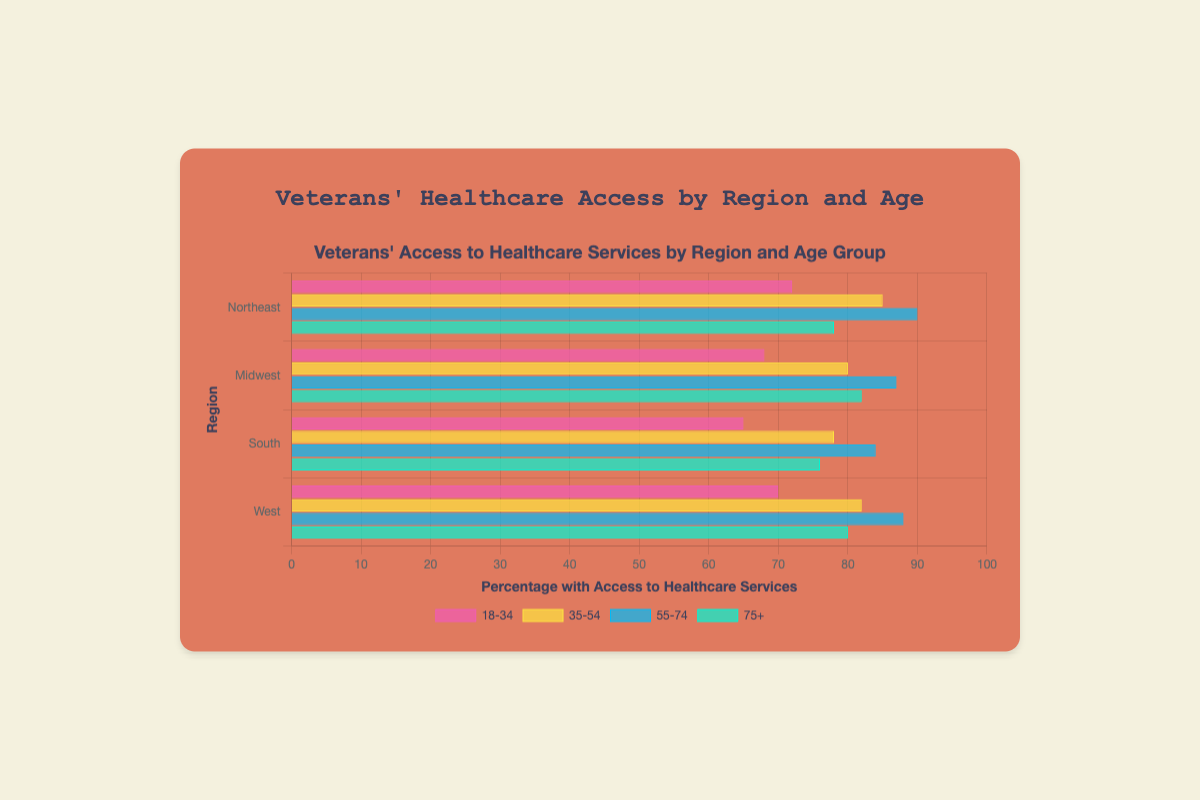Which region has the highest percentage access for the 18-34 age group? By looking at the bar lengths for the 18-34 age group, we can compare across the regions. The Northeast region has the highest percentage access with 72%.
Answer: Northeast Which age group has the lowest percentage access in the Midwest region? We compare the bar lengths for the Midwest region across all age groups. The 18-34 group has the shortest bar with 68%.
Answer: 18-34 Which age group in the South has the highest percentage access? By examining the bar lengths in the South region for all age groups, the 55-74 age group has the longest bar with 84%.
Answer: 55-74 Which regions have a higher percentage access to healthcare services for the 75+ age group than the 18-34 age group? Compare the bar lengths for the 75+ and 18-34 age groups in each region:
1. Northeast: 75+ (78%) > 18-34 (72%)
2. Midwest: 75+ (82%) > 18-34 (68%)
3. South: 75+ (76%) > 18-34 (65%)
4. West: 75+ (80%) > 18-34 (70%)
All regions meet this condition.
Answer: Northeast, Midwest, South, West What is the average percentage access to healthcare services for the Northeast region across all age groups? Sum the percentage access for all age groups in the Northeast and divide by the number of age groups: (72 + 85 + 90 + 78) / 4 = 325 / 4 = 81.25
Answer: 81.25 In which region is the disparity between the highest and lowest percentage access the greatest? Calculate the disparity for each region by subtracting the lowest percentage from the highest:
1. Northeast: 90% - 72% = 18%
2. Midwest: 87% - 68% = 19%
3. South: 84% - 65% = 19%
4. West: 88% - 70% = 18%
The Midwest and South have the greatest disparities, both at 19%.
Answer: Midwest and South Which age group shows the most consistent access to healthcare services across all regions? Evaluate the range (difference between highest and lowest percentage) for each age group across all regions:
1. 18-34: Range = 72% - 65% = 7%
2. 35-54: Range = 85% - 78% = 7%
3. 55-74: Range = 90% - 84% = 6%
4. 75+: Range = 82% - 76% = 6%
The 55-74 and 75+ age groups show the most consistent access with the smallest range of 6%.
Answer: 55-74 and 75+ What is the combined percentage access for veterans aged 18-34 in the Midwest and West regions? Add the percentages for the 18-34 age group in the Midwest and West: 68% (Midwest) + 70% (West) = 138%
Answer: 138 